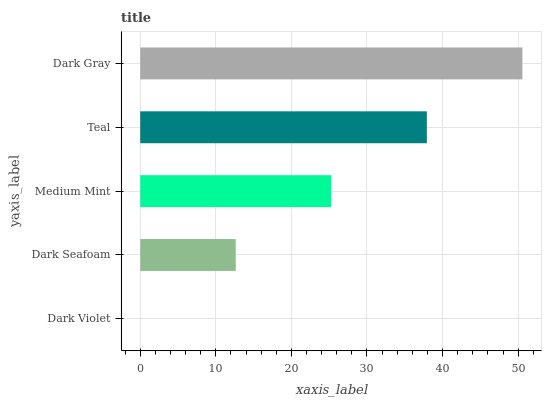Is Dark Violet the minimum?
Answer yes or no. Yes. Is Dark Gray the maximum?
Answer yes or no. Yes. Is Dark Seafoam the minimum?
Answer yes or no. No. Is Dark Seafoam the maximum?
Answer yes or no. No. Is Dark Seafoam greater than Dark Violet?
Answer yes or no. Yes. Is Dark Violet less than Dark Seafoam?
Answer yes or no. Yes. Is Dark Violet greater than Dark Seafoam?
Answer yes or no. No. Is Dark Seafoam less than Dark Violet?
Answer yes or no. No. Is Medium Mint the high median?
Answer yes or no. Yes. Is Medium Mint the low median?
Answer yes or no. Yes. Is Dark Violet the high median?
Answer yes or no. No. Is Dark Seafoam the low median?
Answer yes or no. No. 